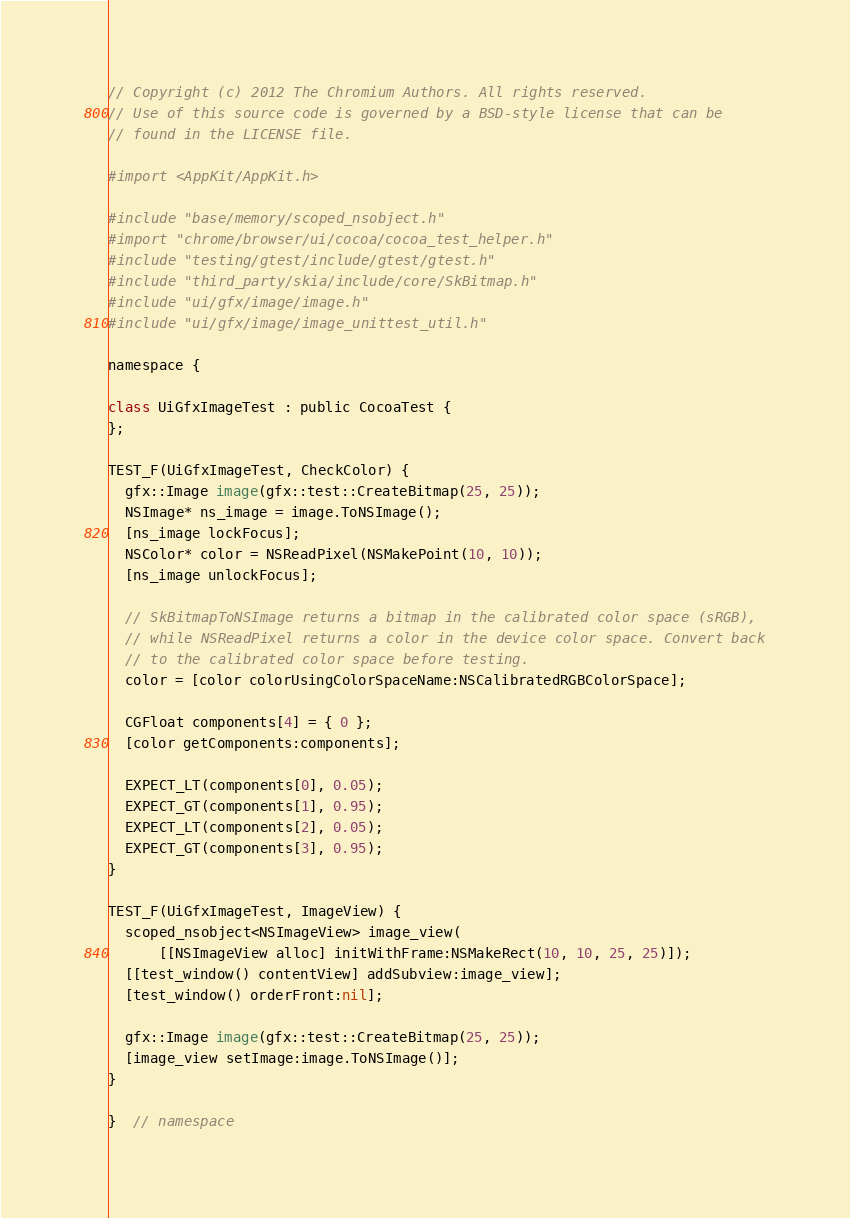<code> <loc_0><loc_0><loc_500><loc_500><_ObjectiveC_>// Copyright (c) 2012 The Chromium Authors. All rights reserved.
// Use of this source code is governed by a BSD-style license that can be
// found in the LICENSE file.

#import <AppKit/AppKit.h>

#include "base/memory/scoped_nsobject.h"
#import "chrome/browser/ui/cocoa/cocoa_test_helper.h"
#include "testing/gtest/include/gtest/gtest.h"
#include "third_party/skia/include/core/SkBitmap.h"
#include "ui/gfx/image/image.h"
#include "ui/gfx/image/image_unittest_util.h"

namespace {

class UiGfxImageTest : public CocoaTest {
};

TEST_F(UiGfxImageTest, CheckColor) {
  gfx::Image image(gfx::test::CreateBitmap(25, 25));
  NSImage* ns_image = image.ToNSImage();
  [ns_image lockFocus];
  NSColor* color = NSReadPixel(NSMakePoint(10, 10));
  [ns_image unlockFocus];

  // SkBitmapToNSImage returns a bitmap in the calibrated color space (sRGB),
  // while NSReadPixel returns a color in the device color space. Convert back
  // to the calibrated color space before testing.
  color = [color colorUsingColorSpaceName:NSCalibratedRGBColorSpace];

  CGFloat components[4] = { 0 };
  [color getComponents:components];

  EXPECT_LT(components[0], 0.05);
  EXPECT_GT(components[1], 0.95);
  EXPECT_LT(components[2], 0.05);
  EXPECT_GT(components[3], 0.95);
}

TEST_F(UiGfxImageTest, ImageView) {
  scoped_nsobject<NSImageView> image_view(
      [[NSImageView alloc] initWithFrame:NSMakeRect(10, 10, 25, 25)]);
  [[test_window() contentView] addSubview:image_view];
  [test_window() orderFront:nil];

  gfx::Image image(gfx::test::CreateBitmap(25, 25));
  [image_view setImage:image.ToNSImage()];
}

}  // namespace
</code> 